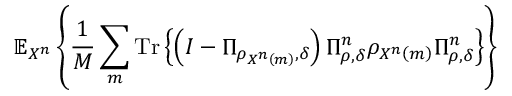Convert formula to latex. <formula><loc_0><loc_0><loc_500><loc_500>\mathbb { E } _ { X ^ { n } } \left \{ { \frac { 1 } { M } } \sum _ { m } { T r } \left \{ \left ( I - \Pi _ { \rho _ { X ^ { n } \left ( m \right ) } , \delta } \right ) \Pi _ { \rho , \delta } ^ { n } \rho _ { X ^ { n } \left ( m \right ) } \Pi _ { \rho , \delta } ^ { n } \right \} \right \}</formula> 